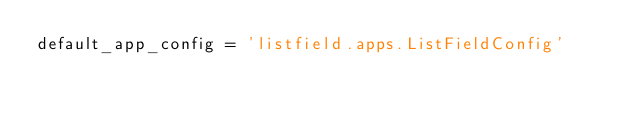<code> <loc_0><loc_0><loc_500><loc_500><_Python_>default_app_config = 'listfield.apps.ListFieldConfig'</code> 